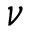<formula> <loc_0><loc_0><loc_500><loc_500>\nu</formula> 